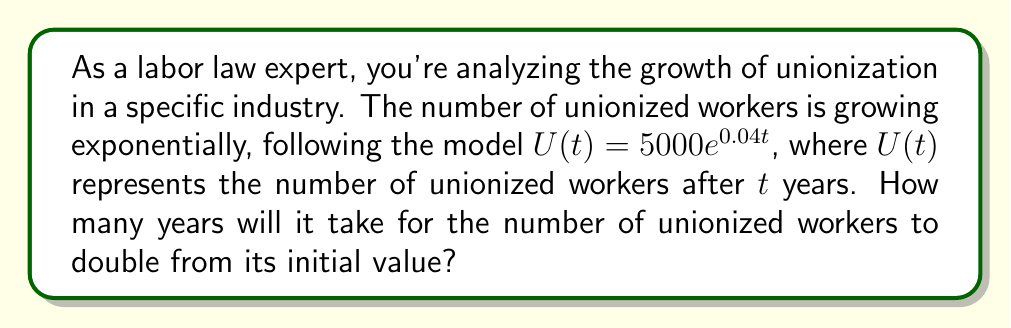Help me with this question. To solve this problem, we'll follow these steps:

1) The initial number of unionized workers is $U(0) = 5000e^{0.04(0)} = 5000$.

2) We want to find $t$ when $U(t) = 2 \cdot 5000 = 10000$.

3) Set up the equation:
   $$10000 = 5000e^{0.04t}$$

4) Divide both sides by 5000:
   $$2 = e^{0.04t}$$

5) Take the natural logarithm of both sides:
   $$\ln(2) = \ln(e^{0.04t})$$

6) Simplify the right side using the properties of logarithms:
   $$\ln(2) = 0.04t$$

7) Solve for $t$:
   $$t = \frac{\ln(2)}{0.04}$$

8) Calculate the result:
   $$t = \frac{0.693147...}{0.04} \approx 17.32867...$$

9) Round to the nearest year, as we're dealing with whole years in this context.
Answer: 17 years 